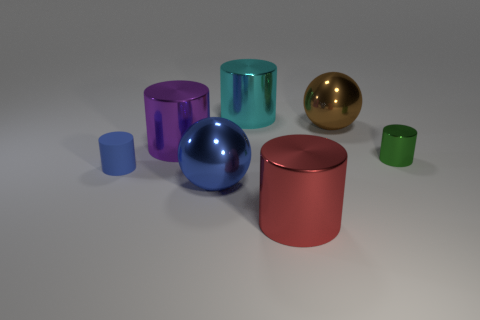Can you describe the material and surface qualities of the objects in the image? Absolutely. The objects in the image display characteristics of reflective, glossy materials, likely metallic or glass-like in nature. The surfaces show signs of specular highlights, indicating shiny textures that reflect the light source. Each object has a distinct color and appears smooth, without visible imperfections or texture variation. 